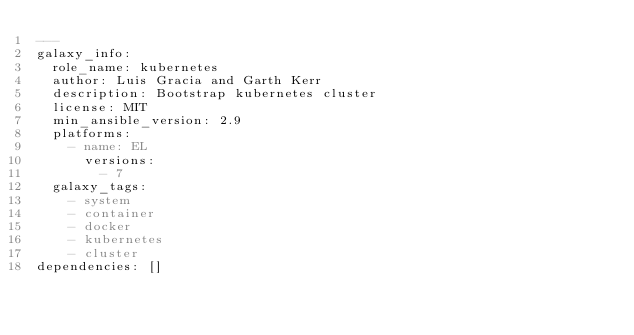<code> <loc_0><loc_0><loc_500><loc_500><_YAML_>---
galaxy_info:
  role_name: kubernetes
  author: Luis Gracia and Garth Kerr
  description: Bootstrap kubernetes cluster
  license: MIT
  min_ansible_version: 2.9
  platforms:
    - name: EL
      versions:
        - 7
  galaxy_tags:
    - system
    - container
    - docker
    - kubernetes
    - cluster
dependencies: []
</code> 